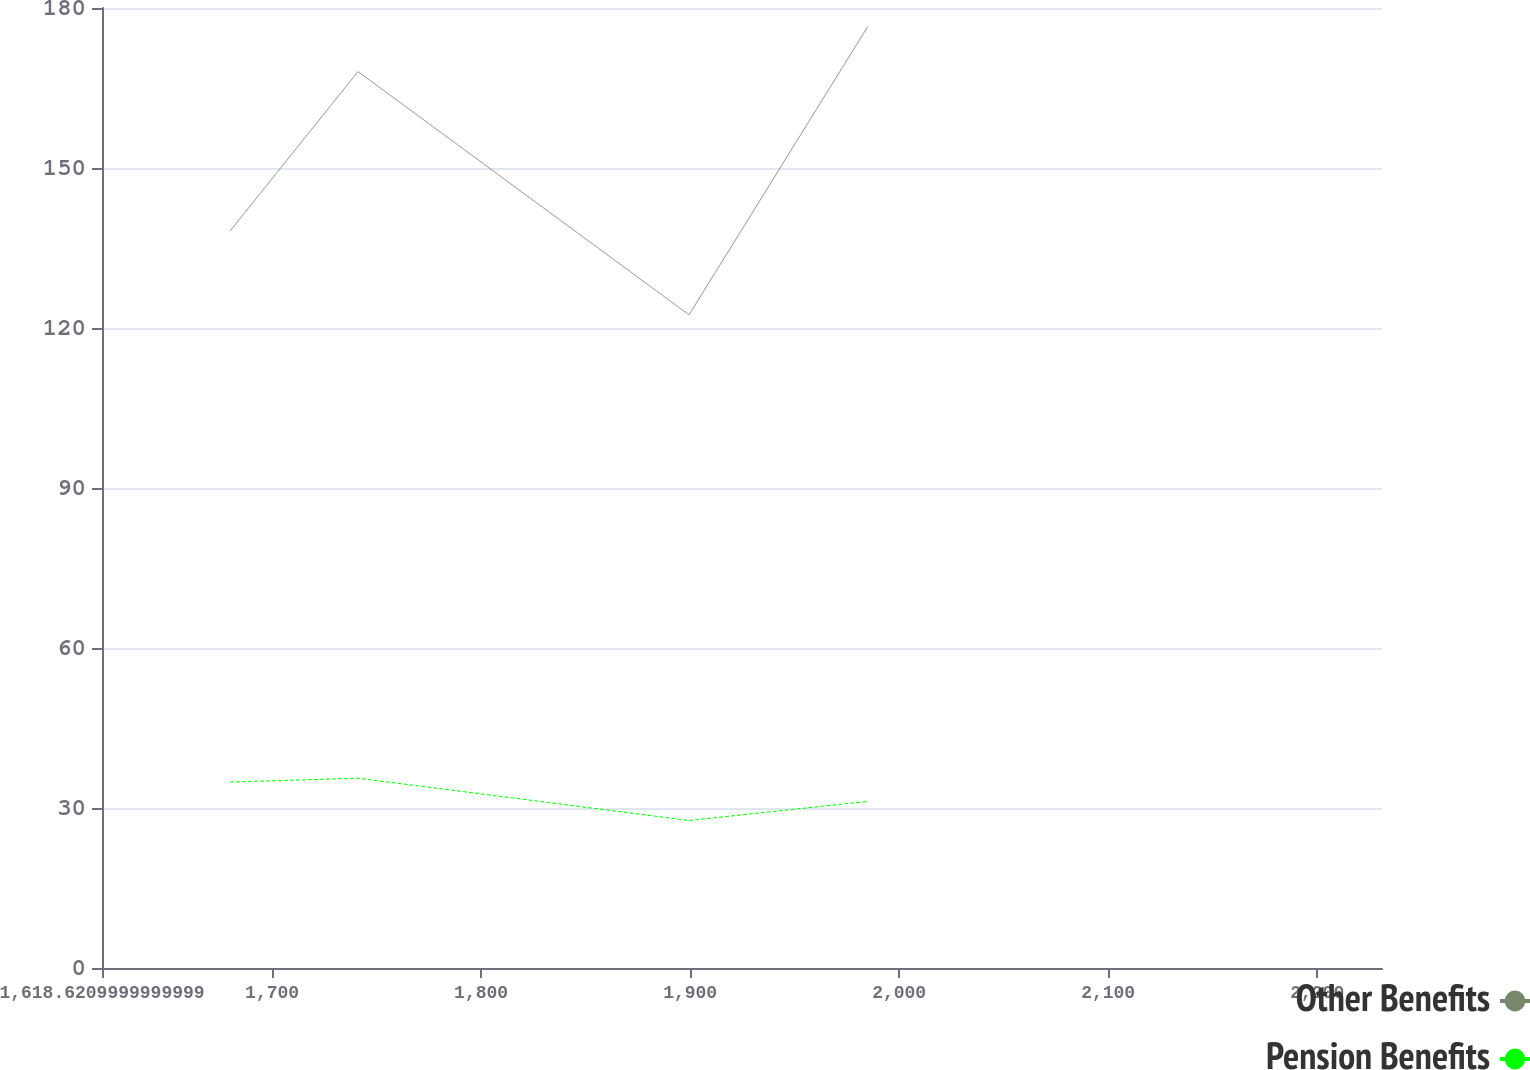<chart> <loc_0><loc_0><loc_500><loc_500><line_chart><ecel><fcel>Other Benefits<fcel>Pension Benefits<nl><fcel>1679.86<fcel>138.17<fcel>34.86<nl><fcel>1741.1<fcel>168.08<fcel>35.59<nl><fcel>1899.46<fcel>122.47<fcel>27.66<nl><fcel>1985<fcel>176.53<fcel>31.24<nl><fcel>2292.25<fcel>132.76<fcel>31.97<nl></chart> 